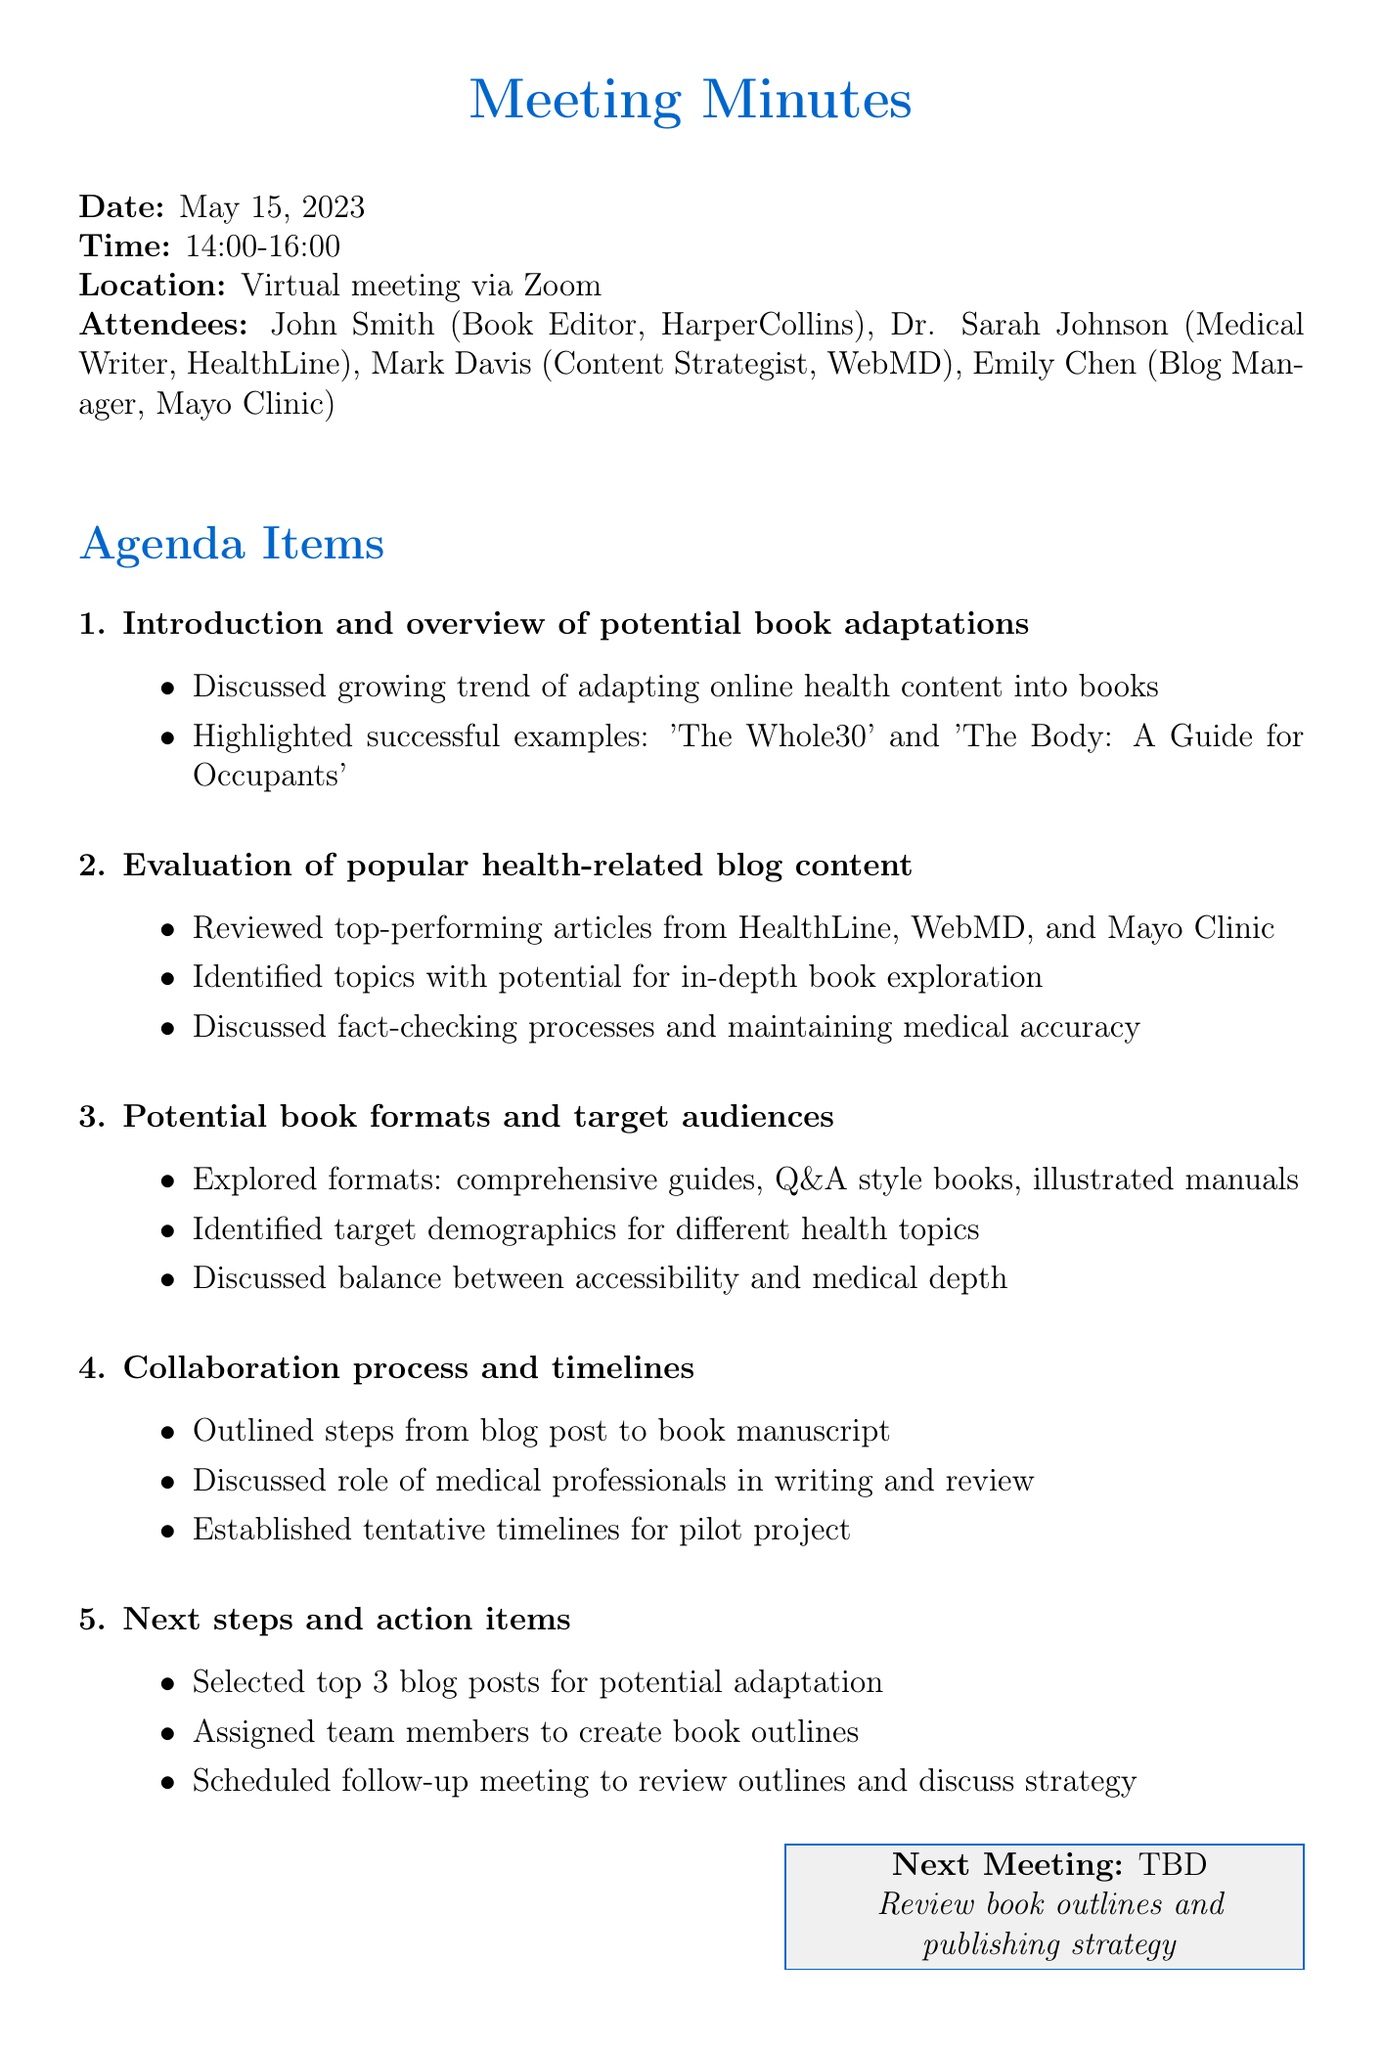What is the date of the meeting? The date of the meeting is explicitly stated in the document under meeting details.
Answer: May 15, 2023 Who is the Book Editor representing HarperCollins? The document lists attendees, including their roles and affiliations.
Answer: John Smith What is one example of a successful book adaptation mentioned? The agenda discusses successful book adaptation examples in the context of potential adaptations.
Answer: The Whole30 Which platforms' blog content was evaluated for adaptation potential? The evaluation section identifies specific blogs that were reviewed for popular articles.
Answer: HealthLine, WebMD, and Mayo Clinic What are two proposed book formats discussed in the meeting? The agenda provides various formats that could be explored for the book adaptations.
Answer: Comprehensive guides, Q&A style books What key process is discussed regarding the collaboration towards creating a book? The collaboration section outlines important steps in the adaptation process from blog to book.
Answer: Outline the steps from blog post to book manuscript What action item involves a follow-up meeting? The next steps highlight planned actions, specifically mentioning the follow-up meeting.
Answer: Review outlines and discuss publishing strategy How many blog posts have been selected for potential adaptation? The document states in the next steps how many blog posts are to be adapted.
Answer: Top 3 